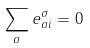Convert formula to latex. <formula><loc_0><loc_0><loc_500><loc_500>\sum _ { a } e ^ { \sigma } _ { a i } = 0</formula> 